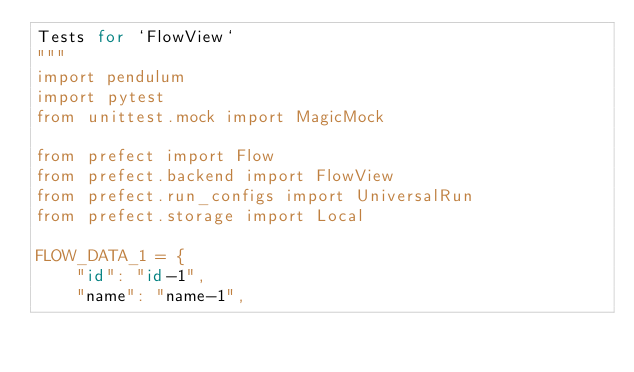Convert code to text. <code><loc_0><loc_0><loc_500><loc_500><_Python_>Tests for `FlowView`
"""
import pendulum
import pytest
from unittest.mock import MagicMock

from prefect import Flow
from prefect.backend import FlowView
from prefect.run_configs import UniversalRun
from prefect.storage import Local

FLOW_DATA_1 = {
    "id": "id-1",
    "name": "name-1",</code> 